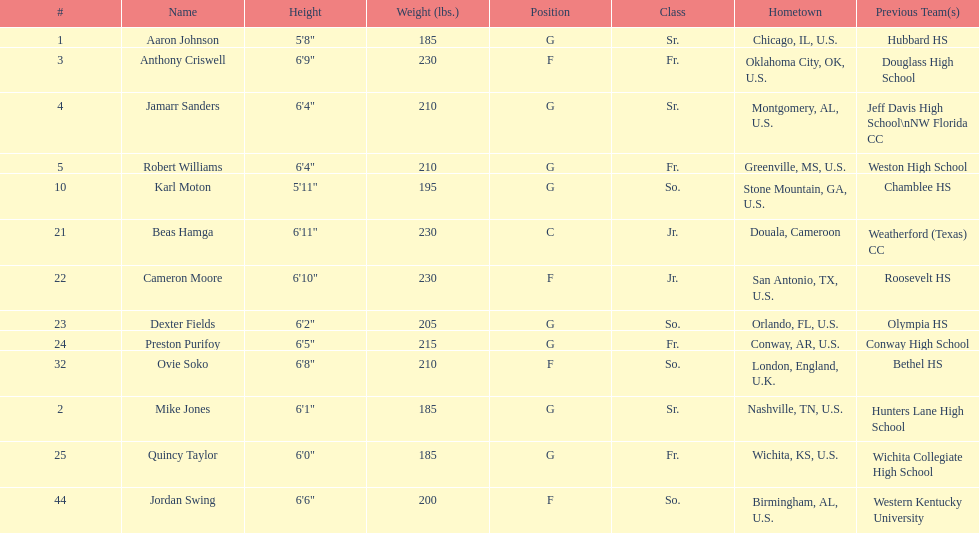How many total forwards are on the team? 4. 